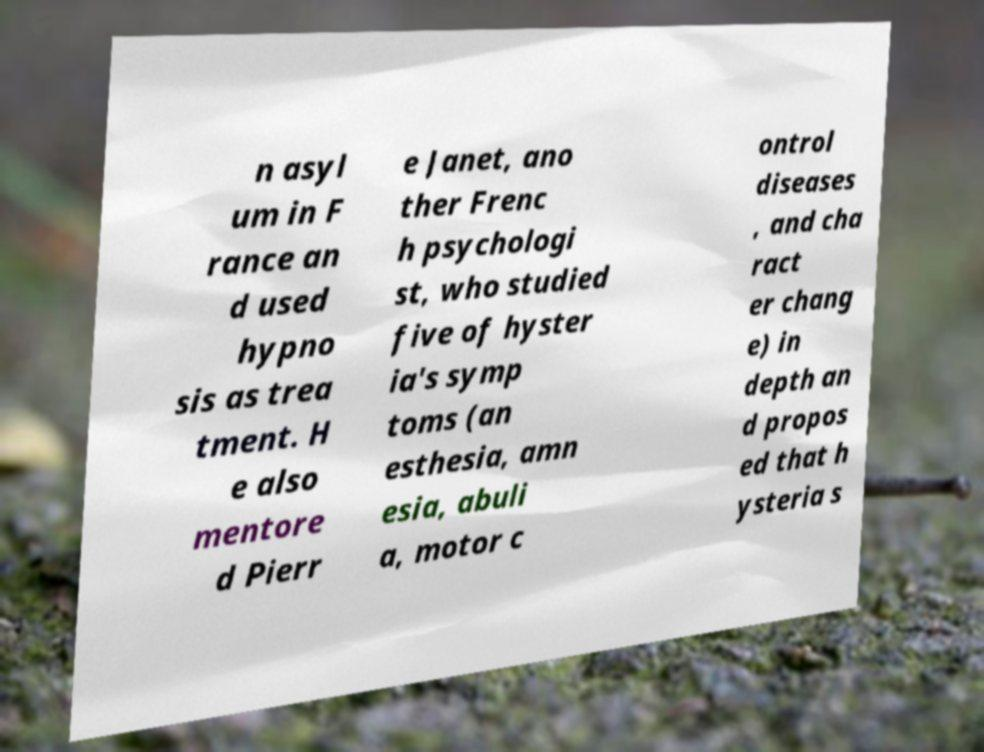For documentation purposes, I need the text within this image transcribed. Could you provide that? n asyl um in F rance an d used hypno sis as trea tment. H e also mentore d Pierr e Janet, ano ther Frenc h psychologi st, who studied five of hyster ia's symp toms (an esthesia, amn esia, abuli a, motor c ontrol diseases , and cha ract er chang e) in depth an d propos ed that h ysteria s 